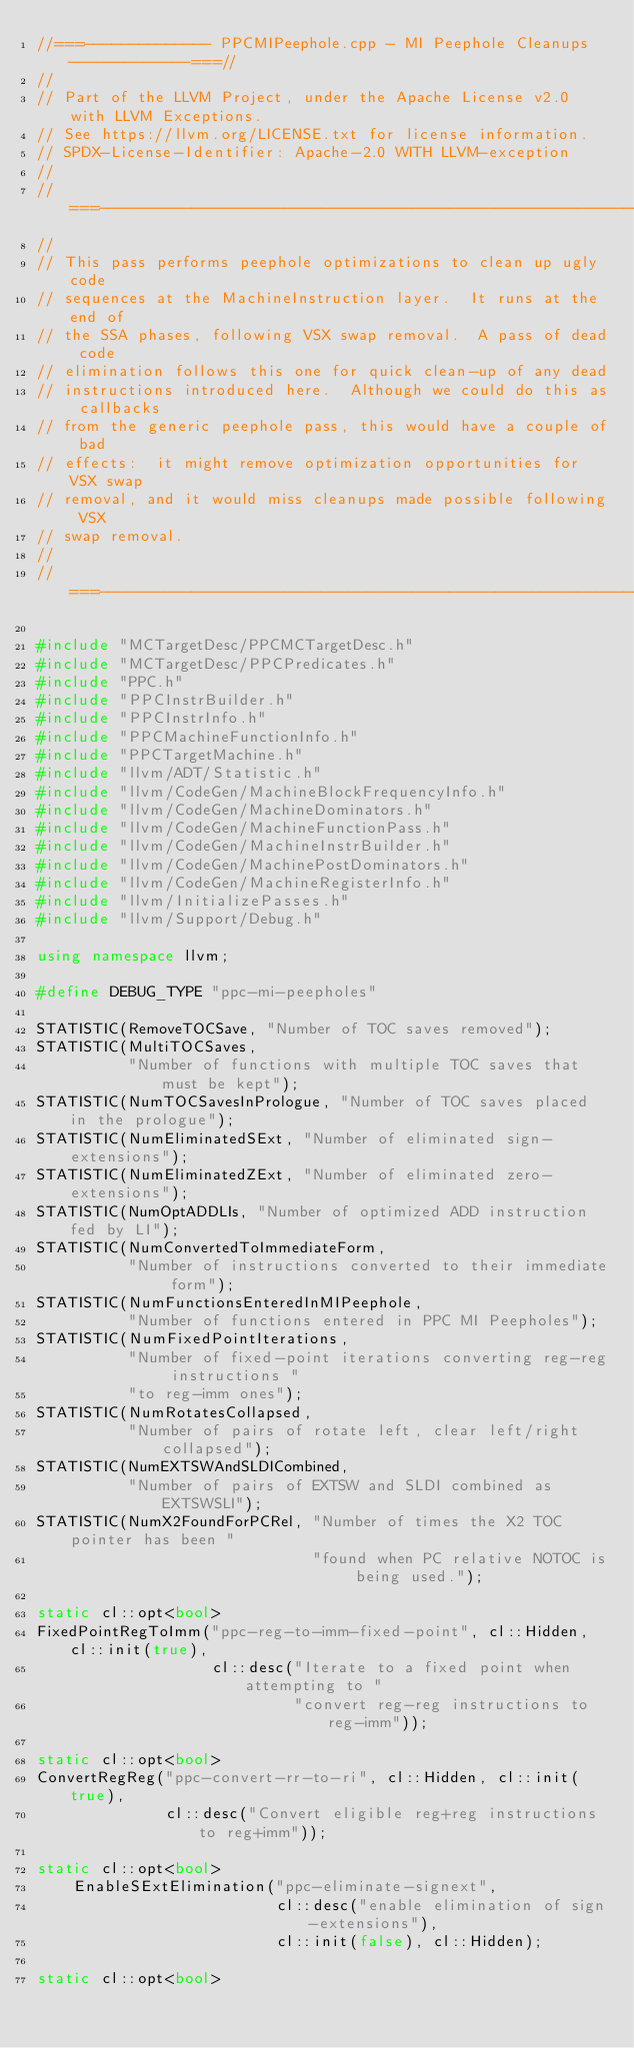<code> <loc_0><loc_0><loc_500><loc_500><_C++_>//===-------------- PPCMIPeephole.cpp - MI Peephole Cleanups -------------===//
//
// Part of the LLVM Project, under the Apache License v2.0 with LLVM Exceptions.
// See https://llvm.org/LICENSE.txt for license information.
// SPDX-License-Identifier: Apache-2.0 WITH LLVM-exception
//
//===---------------------------------------------------------------------===//
//
// This pass performs peephole optimizations to clean up ugly code
// sequences at the MachineInstruction layer.  It runs at the end of
// the SSA phases, following VSX swap removal.  A pass of dead code
// elimination follows this one for quick clean-up of any dead
// instructions introduced here.  Although we could do this as callbacks
// from the generic peephole pass, this would have a couple of bad
// effects:  it might remove optimization opportunities for VSX swap
// removal, and it would miss cleanups made possible following VSX
// swap removal.
//
//===---------------------------------------------------------------------===//

#include "MCTargetDesc/PPCMCTargetDesc.h"
#include "MCTargetDesc/PPCPredicates.h"
#include "PPC.h"
#include "PPCInstrBuilder.h"
#include "PPCInstrInfo.h"
#include "PPCMachineFunctionInfo.h"
#include "PPCTargetMachine.h"
#include "llvm/ADT/Statistic.h"
#include "llvm/CodeGen/MachineBlockFrequencyInfo.h"
#include "llvm/CodeGen/MachineDominators.h"
#include "llvm/CodeGen/MachineFunctionPass.h"
#include "llvm/CodeGen/MachineInstrBuilder.h"
#include "llvm/CodeGen/MachinePostDominators.h"
#include "llvm/CodeGen/MachineRegisterInfo.h"
#include "llvm/InitializePasses.h"
#include "llvm/Support/Debug.h"

using namespace llvm;

#define DEBUG_TYPE "ppc-mi-peepholes"

STATISTIC(RemoveTOCSave, "Number of TOC saves removed");
STATISTIC(MultiTOCSaves,
          "Number of functions with multiple TOC saves that must be kept");
STATISTIC(NumTOCSavesInPrologue, "Number of TOC saves placed in the prologue");
STATISTIC(NumEliminatedSExt, "Number of eliminated sign-extensions");
STATISTIC(NumEliminatedZExt, "Number of eliminated zero-extensions");
STATISTIC(NumOptADDLIs, "Number of optimized ADD instruction fed by LI");
STATISTIC(NumConvertedToImmediateForm,
          "Number of instructions converted to their immediate form");
STATISTIC(NumFunctionsEnteredInMIPeephole,
          "Number of functions entered in PPC MI Peepholes");
STATISTIC(NumFixedPointIterations,
          "Number of fixed-point iterations converting reg-reg instructions "
          "to reg-imm ones");
STATISTIC(NumRotatesCollapsed,
          "Number of pairs of rotate left, clear left/right collapsed");
STATISTIC(NumEXTSWAndSLDICombined,
          "Number of pairs of EXTSW and SLDI combined as EXTSWSLI");
STATISTIC(NumX2FoundForPCRel, "Number of times the X2 TOC pointer has been "
                              "found when PC relative NOTOC is being used.");

static cl::opt<bool>
FixedPointRegToImm("ppc-reg-to-imm-fixed-point", cl::Hidden, cl::init(true),
                   cl::desc("Iterate to a fixed point when attempting to "
                            "convert reg-reg instructions to reg-imm"));

static cl::opt<bool>
ConvertRegReg("ppc-convert-rr-to-ri", cl::Hidden, cl::init(true),
              cl::desc("Convert eligible reg+reg instructions to reg+imm"));

static cl::opt<bool>
    EnableSExtElimination("ppc-eliminate-signext",
                          cl::desc("enable elimination of sign-extensions"),
                          cl::init(false), cl::Hidden);

static cl::opt<bool></code> 